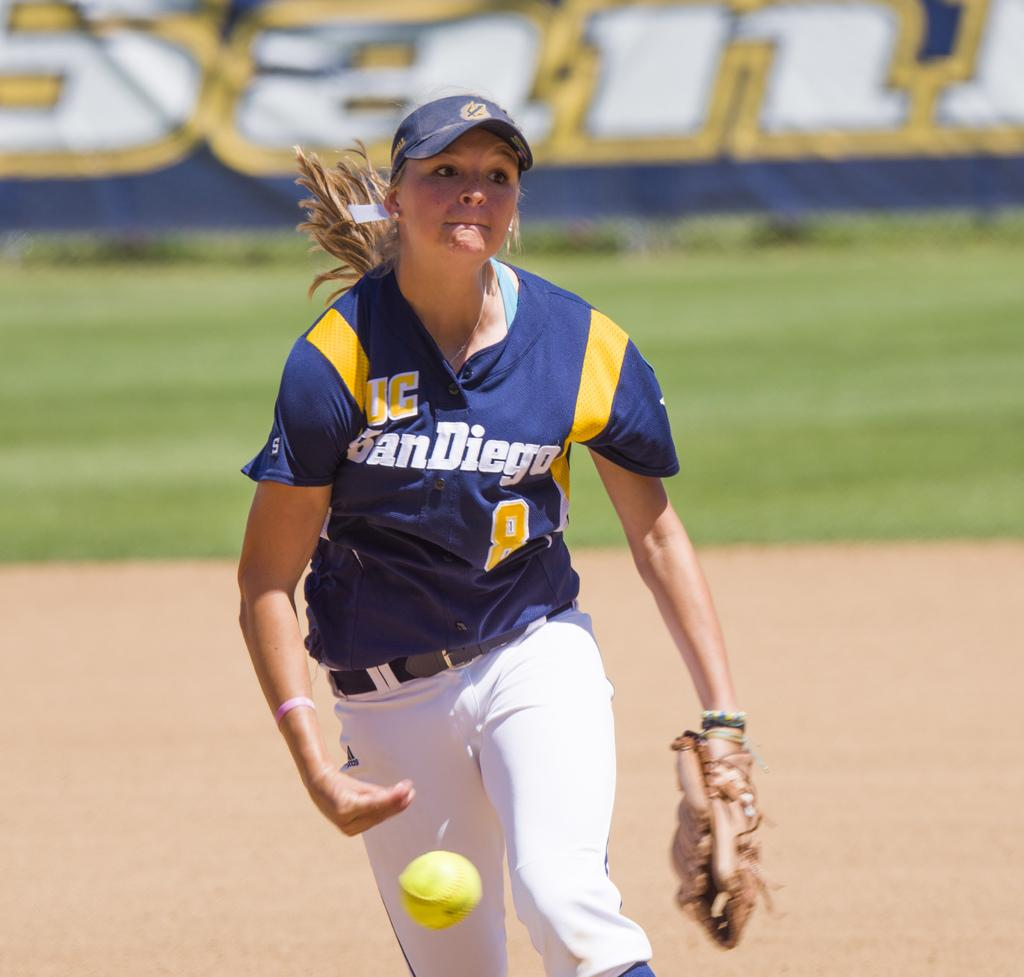<image>
Describe the image concisely. a girl that is wearing a san diego baseball jersey 